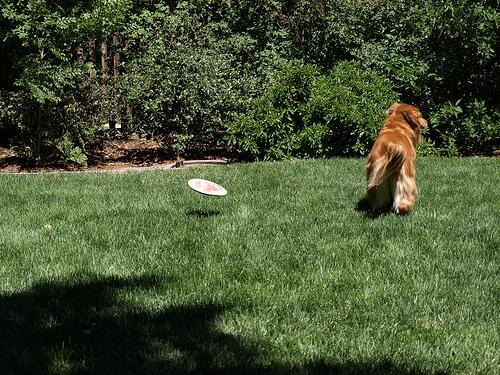What is the key subject in the image, and what action are they performing? The key subject is a brown dog, and it is walking towards a group of bushes. What is the most prominent object in this picture, and what is it doing? The most prominent object is a brown dog, and it is walking in the direction of the bushes. Explain the main subject in the image and its action. The main subject of the image is a brown dog walking toward some green bushes. Identify the primary object in the image and describe its activity. The primary object is a brown dog, which is walking towards a bushy area. What is the main subject of this image, and what are they doing? The main subject is a brown dog walking towards a densely bushy area. Detail the image's primary focus and what the subject appears to be engaged in. The primary focus of the image is a brown dog, who seems to be moving toward some bushes. Describe what the most noticeable object in the image is doing. The most noticeable object, which is a brown dog, is walking towards some bushes. Provide a brief description of the central object in the image and its actions. The central object is a brown dog that is walking in the direction of the bushes. Provide a description of the primary object in the image and its activity. A brown dog is walking towards the bushes and is facing away from the photographer. Describe the primary element in the image and the action it is performing. The primary element is a brown dog walking in the direction of some green bushes. Describe the scene in the image. A brown dog is walking toward bushes, with a white and red frisbee hovering above the grass. There are shadows of a tree and frisbee on the grass, and the dog has a fluffy tail. Estimate the size of the frisbee relative to the dog. The frisbee is smaller than the dog. What colors are the small flowers on the trees? Red and white. How does the grass look in the image? Short, green, and lush. How is the dog facing in relation to the photographer? Facing away from the photographer. What is the size of the frisbee's shadow compared to the frisbee itself? The shadow is slightly smaller than the frisbee. Is the dog looking at the trees or the frisbee? Looking at the trees. Is the grass in the field tall and yellow? The grass in the image is short and green, not tall and yellow. Assess the overall quality of the image. Good quality with clear objects and details. Is the dog playing with a blue ball? There is a dog in the image but it's interacting with a frisbee, not a blue ball. How would you describe the tail of the dog? Wagging brown and white, and fluffy. Identify any anomalies or strange occurrences in the image. No anomalies detected; the scene appears natural and consistent. Read the text and design elements on the frisbee. Red writing and design on the top of the frisbee. List two attributes of the dog in the image. Brown color and fluffy tail. What is the sentiment of the scene with the dog and the frisbee? Positive and playful. Is the frisbee white and red or yellow? White and red. Point out the green bush in front of a dog. X:234 Y:58 Width:153 Height:153 Identify the area where the grass is short and green. X:288 Y:240 Width:65 Height:65 Are there pink flowers on the trees? There are small red flowers on the trees, not pink ones. Identify the object referred to as "a large brown dog." X:358 Y:98 Width:72 Height:72 What are the two different types of shadows on the ground? Shadow of a large tree and black shadow of a frisbee. Can you see a cat in the image? There is no cat in the image, only a dog. Locate the shadow of the frisbee on the grass. X:184 Y:208 Width:40 Height:40 Is the frisbee landing on the pavement? The frisbee is about to land on grass, not pavement. Analyze how the dog is interacting with its surroundings. The dog is walking towards the bushes while facing away from the photographer, possibly paying attention to the frisbee hovering above the grass. Is the dog facing towards the camera? The dog is facing away from the photographer, not towards the camera. 